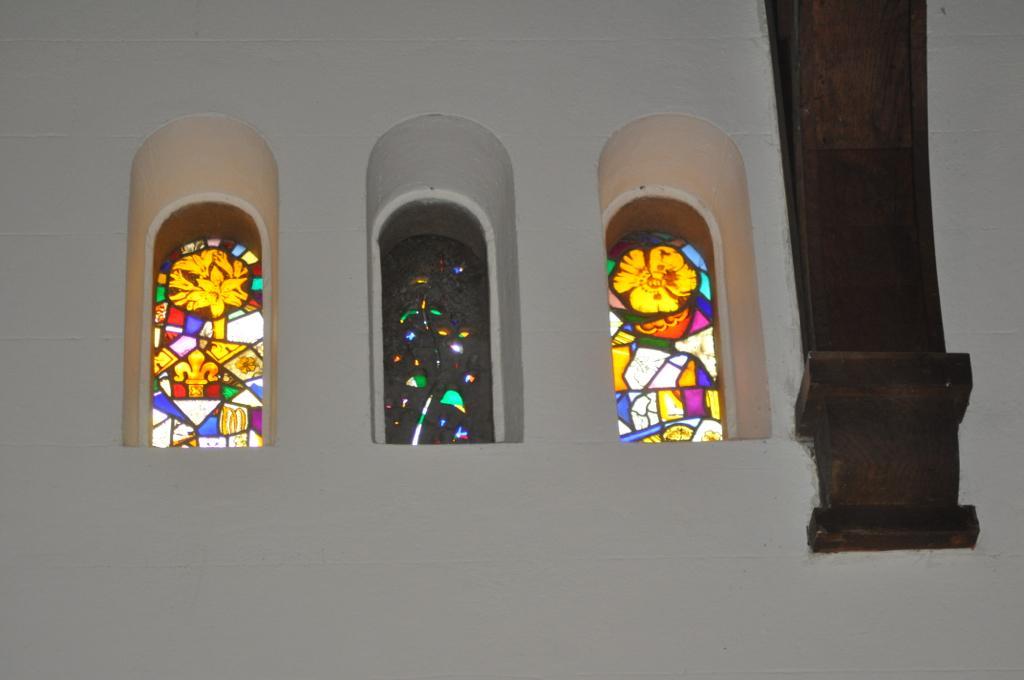How would you summarize this image in a sentence or two? This pictures seems to be clicked inside. On the right we can see the wooden object. In the center we can see the three windows and the wall and we can see the pictures of flowers on the windows. 